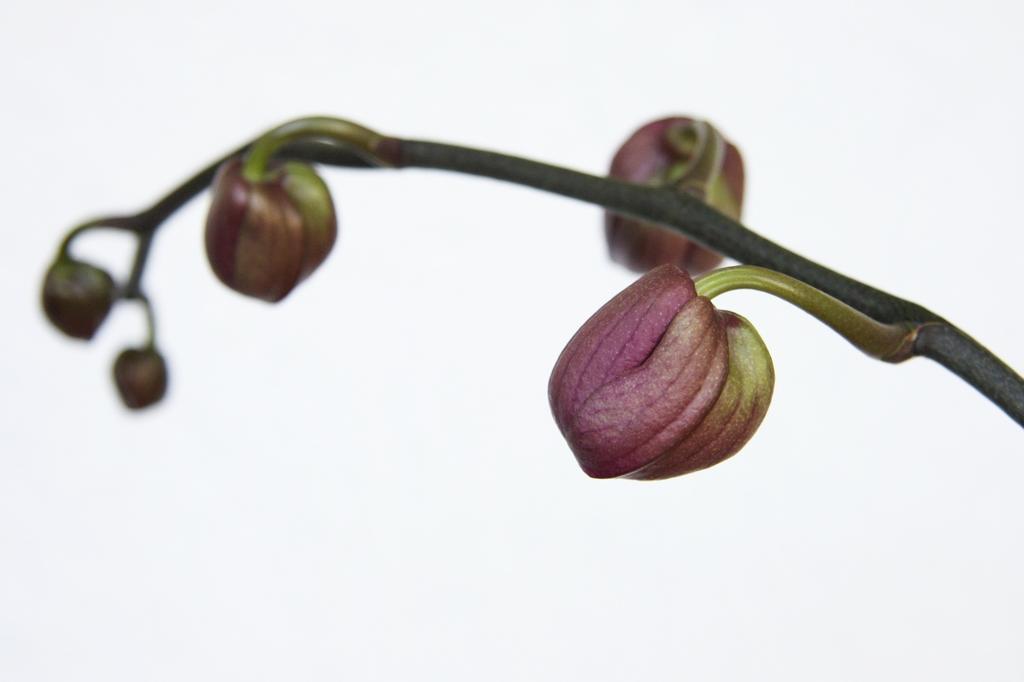Describe this image in one or two sentences. In this image I can see few flower buds which are pink in color to a plant. I can see the white colored background. 